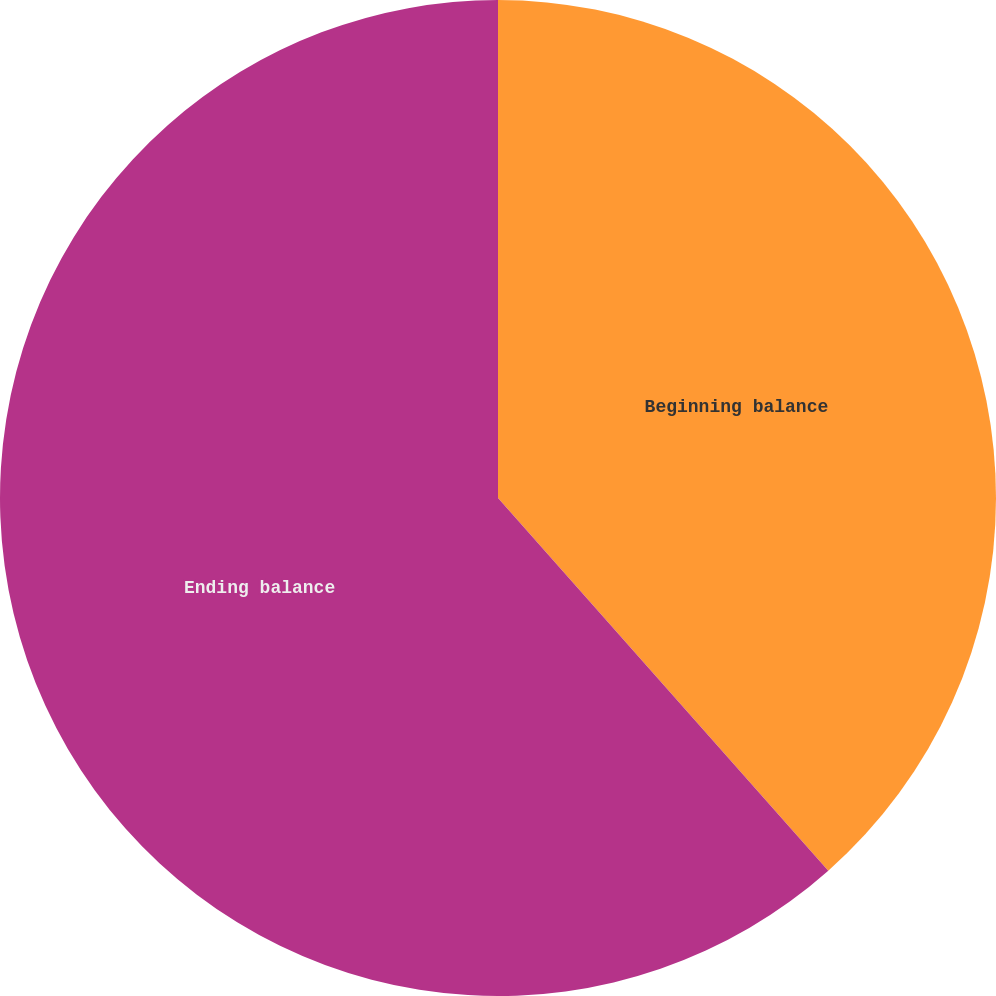<chart> <loc_0><loc_0><loc_500><loc_500><pie_chart><fcel>Beginning balance<fcel>Ending balance<nl><fcel>38.46%<fcel>61.54%<nl></chart> 